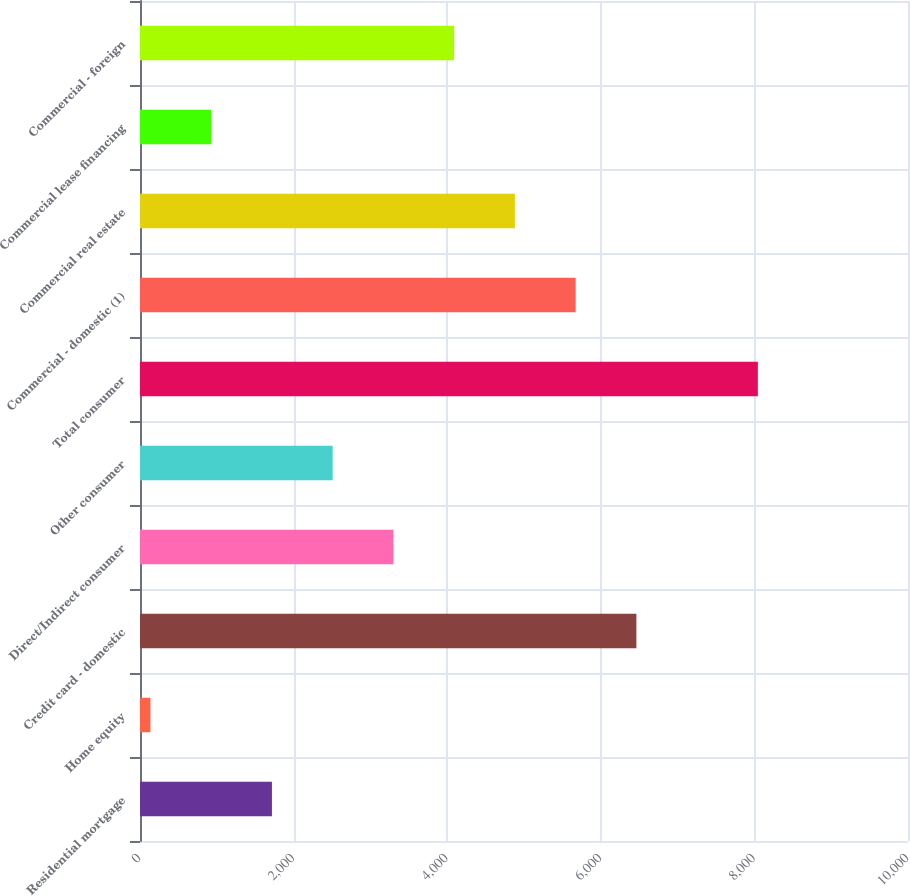Convert chart. <chart><loc_0><loc_0><loc_500><loc_500><bar_chart><fcel>Residential mortgage<fcel>Home equity<fcel>Credit card - domestic<fcel>Direct/Indirect consumer<fcel>Other consumer<fcel>Total consumer<fcel>Commercial - domestic (1)<fcel>Commercial real estate<fcel>Commercial lease financing<fcel>Commercial - foreign<nl><fcel>1717.8<fcel>136<fcel>6463.2<fcel>3299.6<fcel>2508.7<fcel>8045<fcel>5672.3<fcel>4881.4<fcel>926.9<fcel>4090.5<nl></chart> 